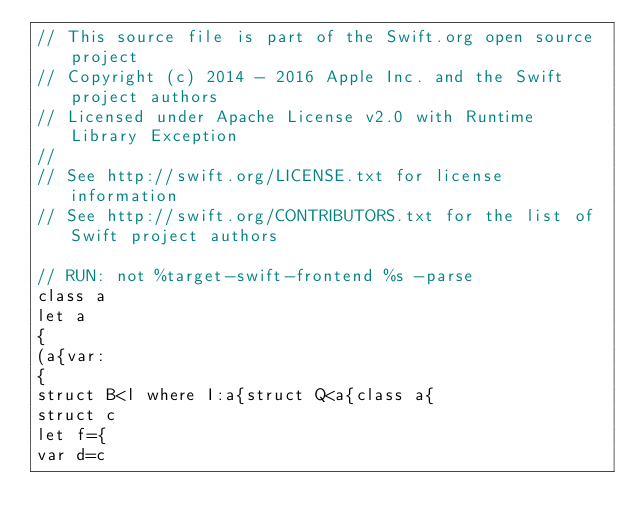Convert code to text. <code><loc_0><loc_0><loc_500><loc_500><_Swift_>// This source file is part of the Swift.org open source project
// Copyright (c) 2014 - 2016 Apple Inc. and the Swift project authors
// Licensed under Apache License v2.0 with Runtime Library Exception
//
// See http://swift.org/LICENSE.txt for license information
// See http://swift.org/CONTRIBUTORS.txt for the list of Swift project authors

// RUN: not %target-swift-frontend %s -parse
class a
let a
{
(a{var:
{
struct B<l where I:a{struct Q<a{class a{
struct c
let f={
var d=c
</code> 